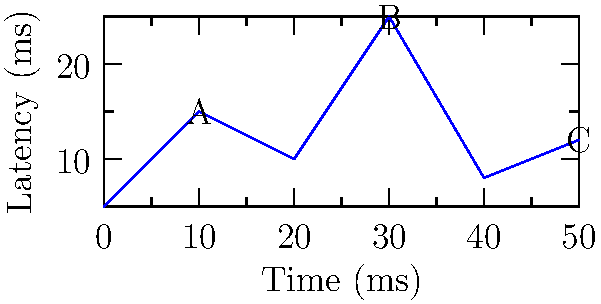In a robot control scenario, network latency is critical for smooth operation. The graph shows latency measurements over time for a robot's control system. Which point on the graph represents the highest risk for control instability, and what is the corresponding latency value? To determine the point with the highest risk for control instability and its corresponding latency value, we need to analyze the graph:

1. The graph shows latency measurements over time, with the x-axis representing time in milliseconds and the y-axis representing latency in milliseconds.

2. Higher latency values generally pose a greater risk for control instability, as they introduce longer delays in the robot's response to commands.

3. We can identify three labeled points on the graph:
   - Point A: (10 ms, 15 ms)
   - Point B: (30 ms, 25 ms)
   - Point C: (50 ms, 12 ms)

4. Comparing the latency values:
   - Point A: 15 ms
   - Point B: 25 ms
   - Point C: 12 ms

5. Point B has the highest latency value at 25 ms.

Therefore, Point B represents the highest risk for control instability, with a corresponding latency value of 25 ms.
Answer: Point B, 25 ms 